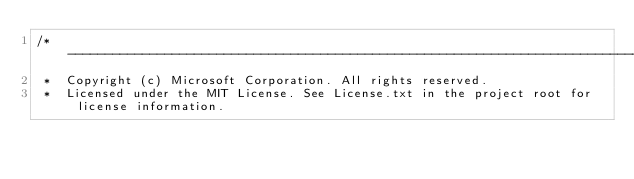<code> <loc_0><loc_0><loc_500><loc_500><_TypeScript_>/*---------------------------------------------------------------------------------------------
 *  Copyright (c) Microsoft Corporation. All rights reserved.
 *  Licensed under the MIT License. See License.txt in the project root for license information.</code> 